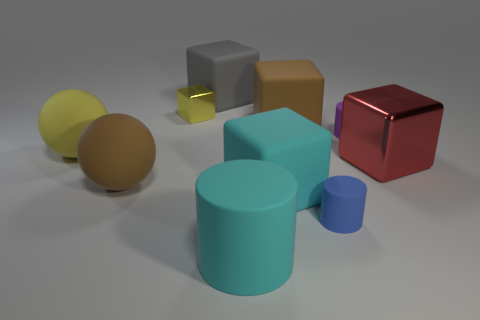Subtract all brown matte blocks. How many blocks are left? 4 Subtract all red blocks. How many blocks are left? 4 Subtract 1 cubes. How many cubes are left? 4 Subtract all brown cubes. Subtract all red cylinders. How many cubes are left? 4 Subtract all cylinders. How many objects are left? 7 Subtract all small blue cylinders. Subtract all large brown spheres. How many objects are left? 8 Add 8 large cylinders. How many large cylinders are left? 9 Add 7 tiny purple rubber cylinders. How many tiny purple rubber cylinders exist? 8 Subtract 0 red cylinders. How many objects are left? 10 